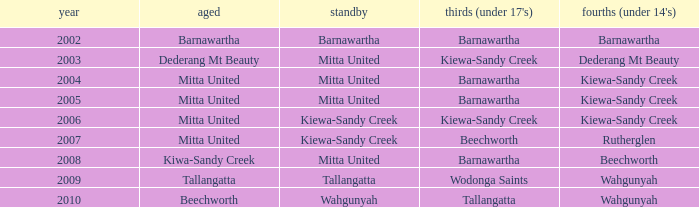Which Thirds (Under 17's) have a Reserve of barnawartha? Barnawartha. 